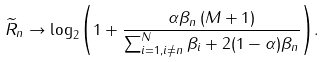Convert formula to latex. <formula><loc_0><loc_0><loc_500><loc_500>{ { \widetilde { R } } _ { n } } \to { \log _ { 2 } } { \left ( { 1 + \frac { { { \alpha } { \beta _ { n } } \left ( { M + 1 } \right ) } } { { \sum _ { i = 1 , i \ne n } ^ { N } { \beta _ { i } } } + 2 ( 1 - \alpha ) { \beta _ { n } } } } \right ) } .</formula> 